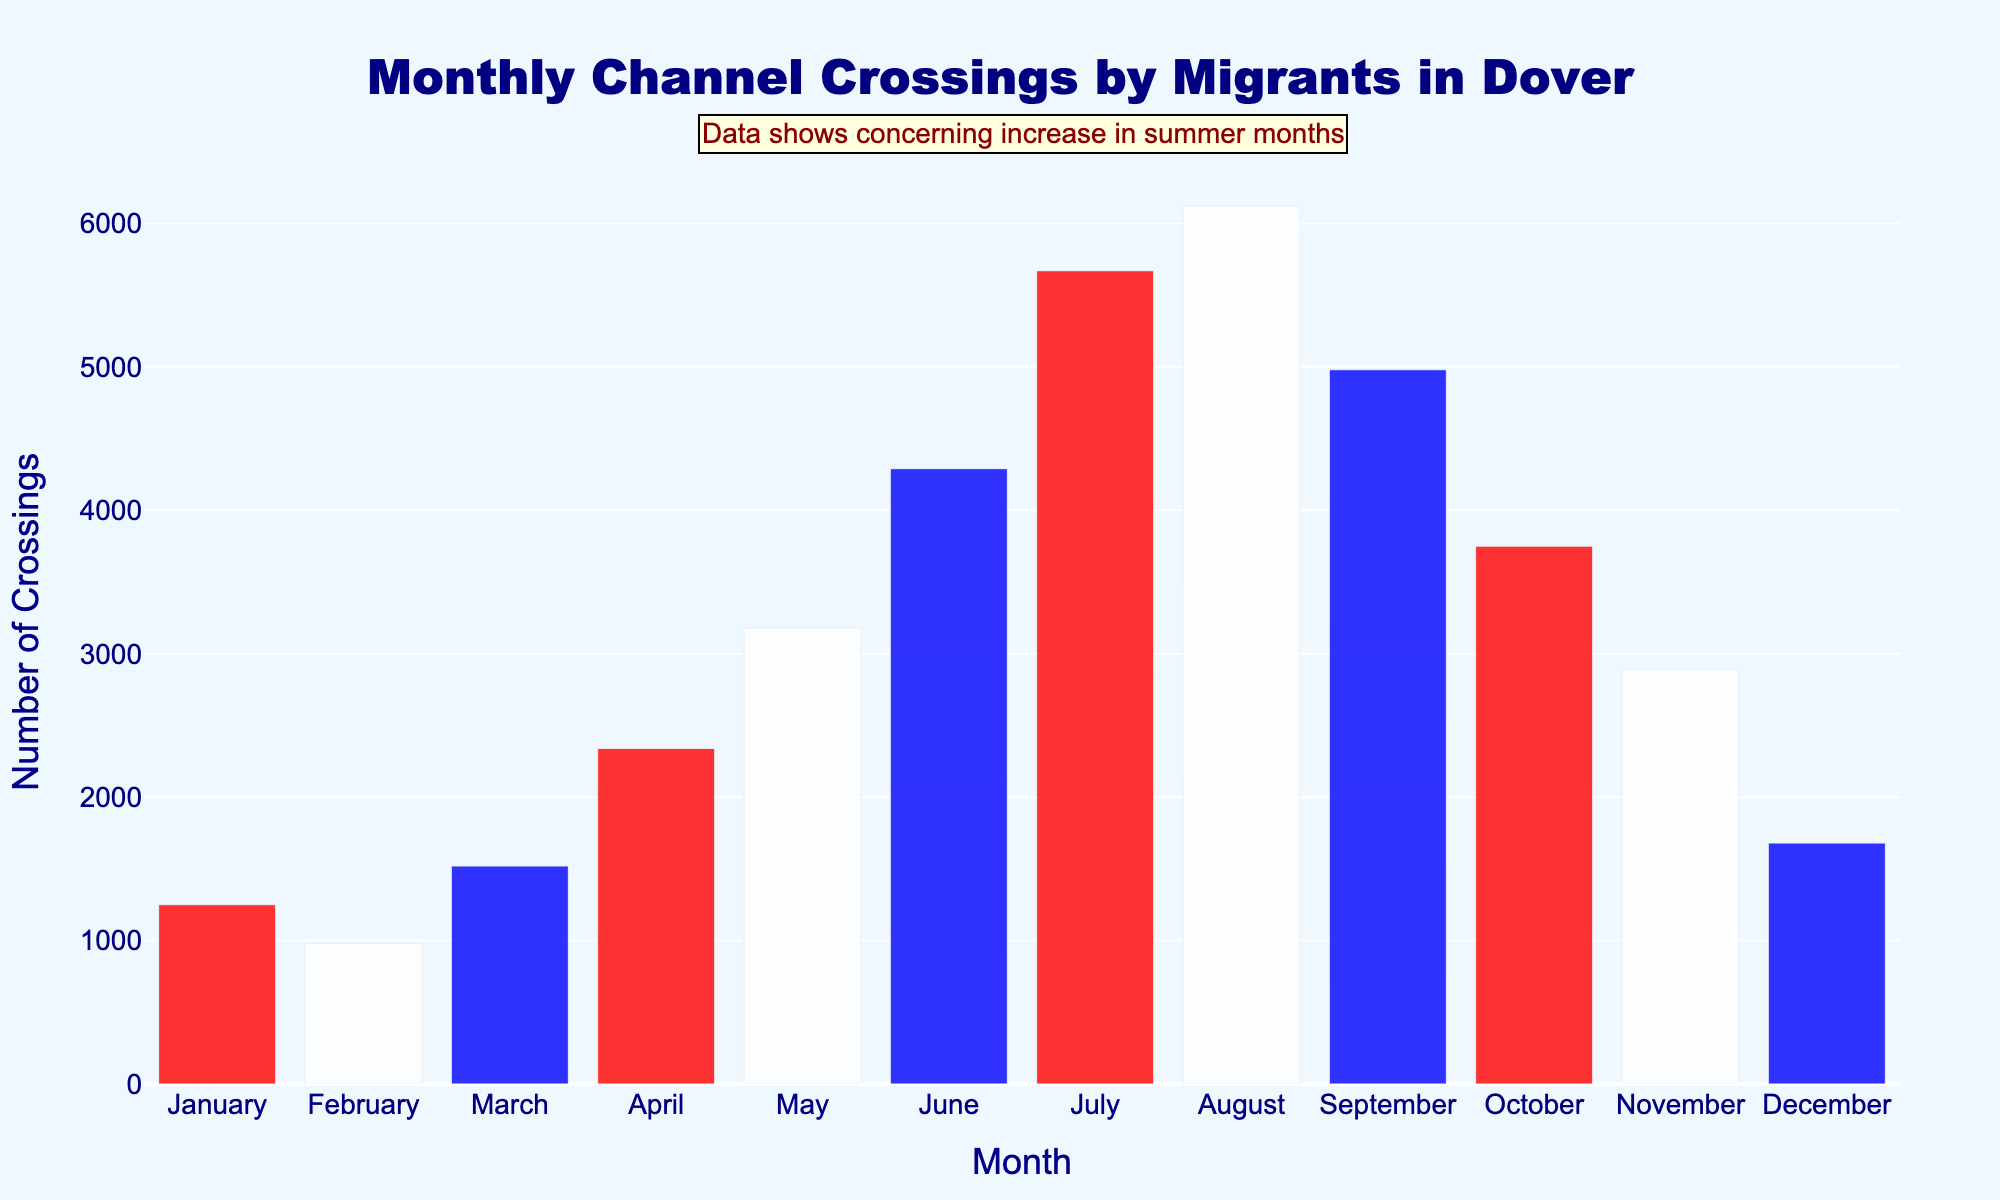What is the title of the histogram? The title is displayed at the top of the histogram, clearly showing the main subject of the visualization.
Answer: Monthly Channel Crossings by Migrants in Dover Which month had the highest number of Channel crossings? Identify the highest bar in the histogram and note the corresponding month on the x-axis below it.
Answer: August Which months had fewer than 2000 Channel crossings? Check each bar's height and refer to the y-axis to see which months' bars do not exceed the 2000 mark.
Answer: January, February, November, December How many Channel crossings occurred in June? Locate the bar for June, and refer to the height of the bar to read the exact number from the y-axis.
Answer: 4290 What is the overall trend in the number of Channel crossings from January to December? Analyze the pattern of the bar heights across the months to determine if there is an overall increase, decrease, or fluctuation.
Answer: Increasing, then decreasing Which three consecutive months had the highest average number of Channel crossings? Calculate the average for different sets of three consecutive months and compare. For instance, (May + June + July) / 3 and (June + July + August) / 3.
Answer: June, July, August How many more Channel crossings were there in July than in April? Subtract the number of crossings in April from the number in July.
Answer: 5670 - 2340 = 3330 What is the difference in the number of Channel crossings between the month with the highest crossings and the month with the lowest crossings? Identify the numbers for the highest and lowest months and subtract the smallest value from the largest.
Answer: 6120 - 980 = 5140 Which season (using approximate 3-month groupings) saw the highest number of Channel crossings? (Winter: Dec-Feb, Spring: Mar-May, Summer: Jun-Aug, Autumn: Sep-Nov) Group the crossings by season: (Dec + Jan + Feb), (Mar + Apr + May), (Jun + Jul + Aug), (Sep + Oct + Nov), then sum each group and compare.
Answer: Summer How do the Channel crossings in May compare with those in November? Compare the heights of the bars for May and November to see which is higher and by how much.
Answer: 3180 (May) vs 2890 (Nov) 